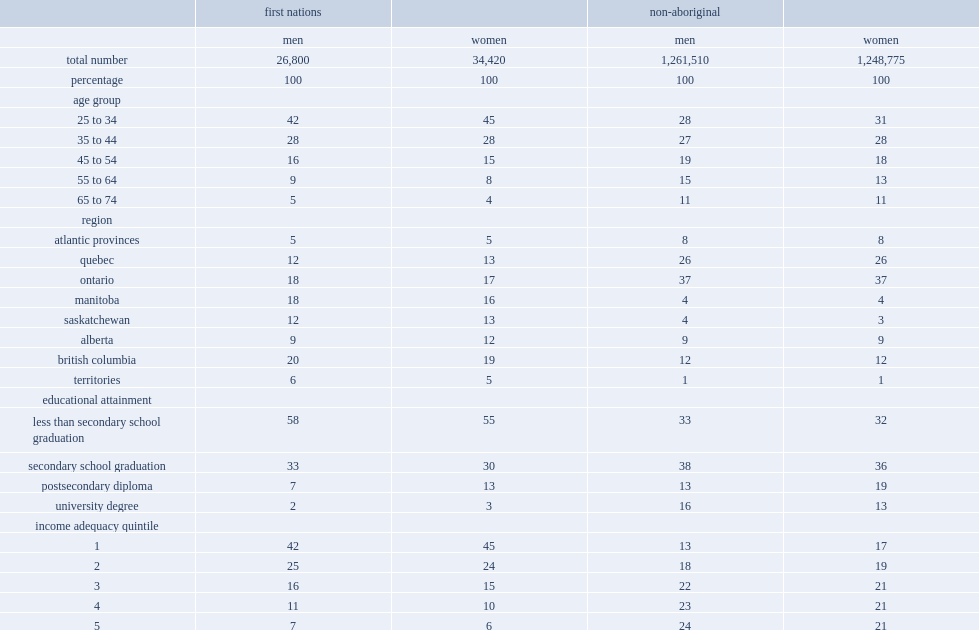How many first nations adults did this study totally examined mortality outcomes for during the 1991-to-2006 period? 61220. How many first nations men did this study totally examined mortality outcomes for during the 1991-to-2006 period? 26800. How many first nations women did this study totally examined mortality outcomes for during the 1991-to-2006 period? 34420. How many non-aboriginal adults did this study totally examined mortality outcomes for during the 1991-to-2006 period? 2510285. How many non-aboriginal men did this study totally examined mortality outcomes for during the 1991-to-2006 period? 1261510. How many non-aboriginal women did this study totally examined mortality outcomes for during the 1991-to-2006 period? 1248775. Which type of adults were younger, non-aboriginial or first nations? First nations. Which type of adults had lower levels of education and income, non-aboriginal or first nations? First nations. Which type of adults were more likely to live in western and northern canada, non-aboriginal or first nations? First nations. 